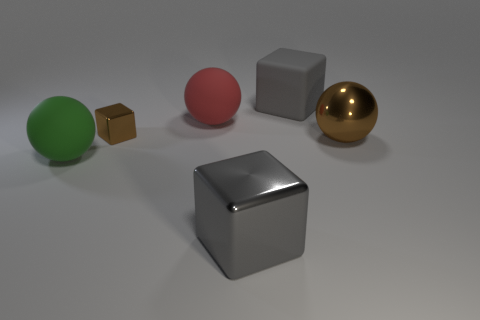Subtract all gray blocks. How many were subtracted if there are1gray blocks left? 1 Subtract all metallic cubes. How many cubes are left? 1 Add 1 green matte objects. How many objects exist? 7 Subtract all green balls. How many balls are left? 2 Subtract all purple cylinders. How many gray blocks are left? 2 Subtract all big cyan spheres. Subtract all large red spheres. How many objects are left? 5 Add 4 large green matte objects. How many large green matte objects are left? 5 Add 5 tiny things. How many tiny things exist? 6 Subtract 0 purple cylinders. How many objects are left? 6 Subtract 1 cubes. How many cubes are left? 2 